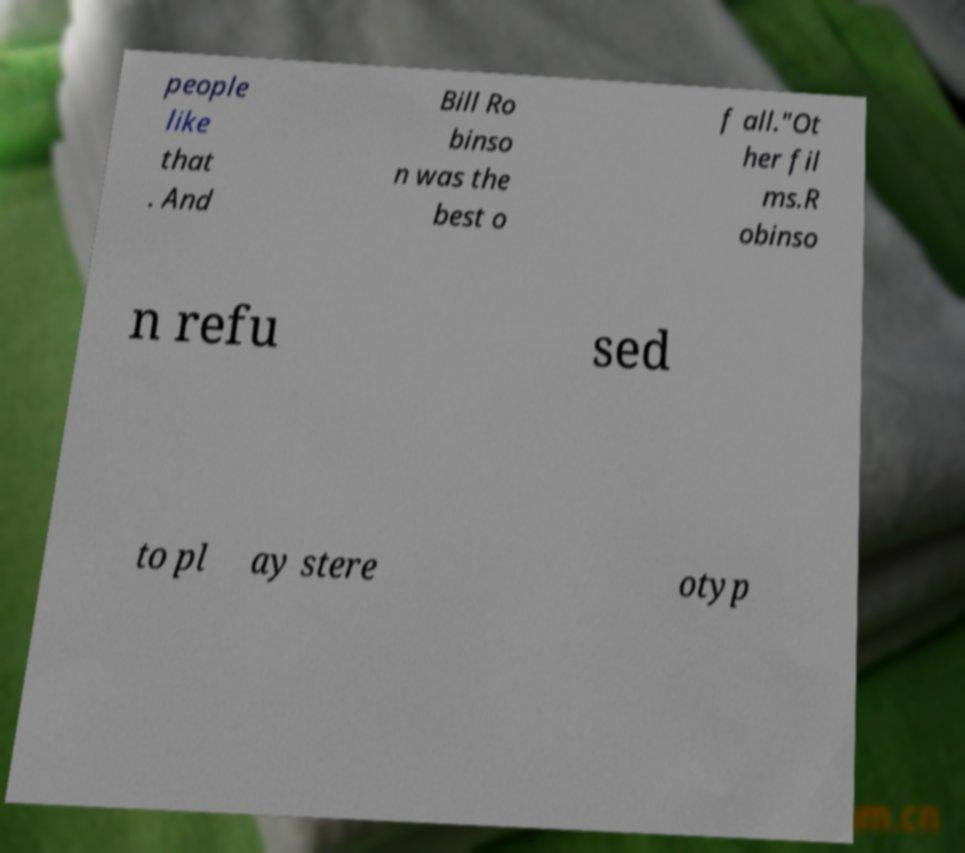Could you assist in decoding the text presented in this image and type it out clearly? people like that . And Bill Ro binso n was the best o f all."Ot her fil ms.R obinso n refu sed to pl ay stere otyp 